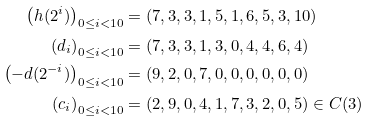<formula> <loc_0><loc_0><loc_500><loc_500>\left ( h ( 2 ^ { i } ) \right ) _ { 0 \leq i < 1 0 } & = ( 7 , 3 , 3 , 1 , 5 , 1 , 6 , 5 , 3 , 1 0 ) \\ \left ( d _ { i } \right ) _ { 0 \leq i < 1 0 } & = ( 7 , 3 , 3 , 1 , 3 , 0 , 4 , 4 , 6 , 4 ) \\ \left ( - d ( 2 ^ { - i } ) \right ) _ { 0 \leq i < 1 0 } & = ( 9 , 2 , 0 , 7 , 0 , 0 , 0 , 0 , 0 , 0 ) \\ \left ( c _ { i } \right ) _ { 0 \leq i < 1 0 } & = ( 2 , 9 , 0 , 4 , 1 , 7 , 3 , 2 , 0 , 5 ) \in C ( 3 )</formula> 